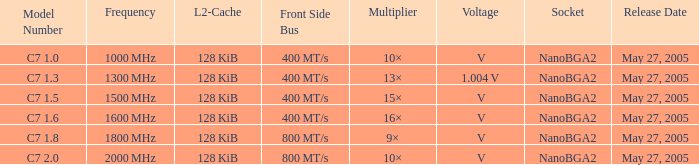0? 1000 MHz. 